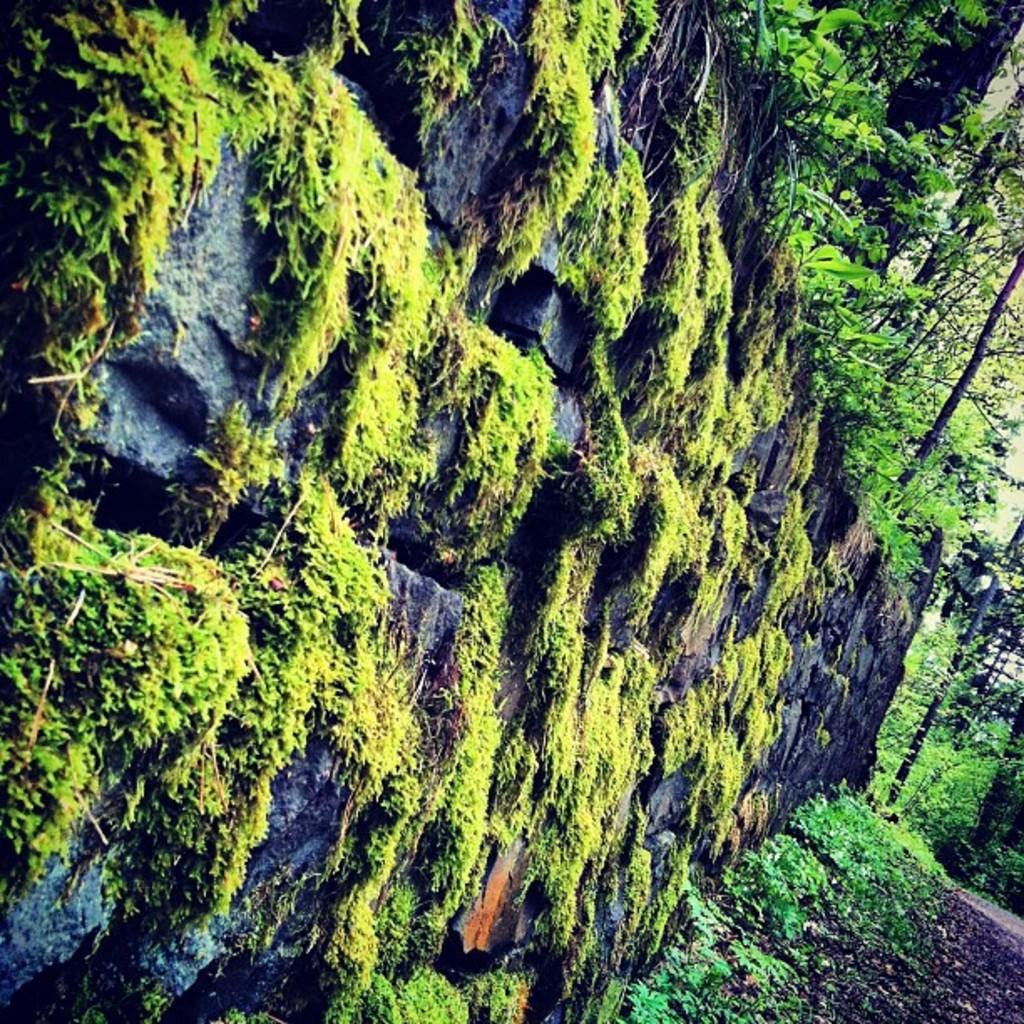In one or two sentences, can you explain what this image depicts? In this image we can see grass on the wall and we can also see trees and plants. 